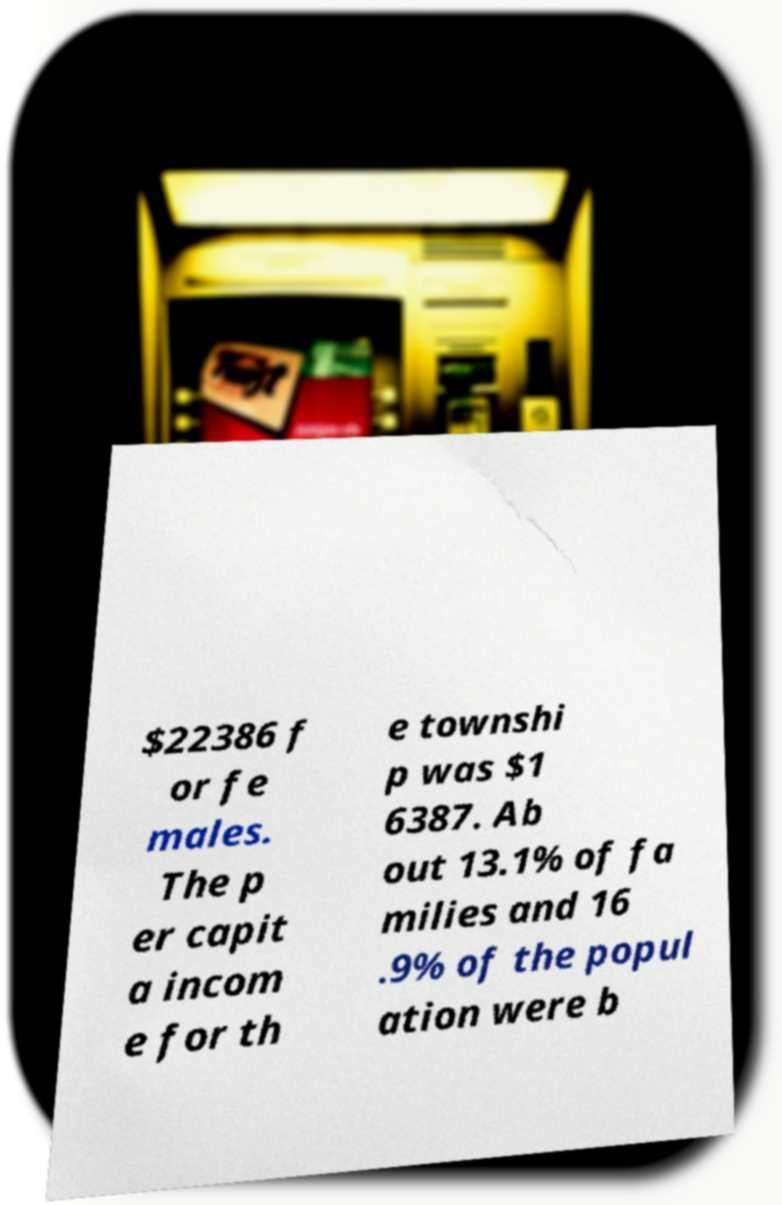Can you read and provide the text displayed in the image?This photo seems to have some interesting text. Can you extract and type it out for me? $22386 f or fe males. The p er capit a incom e for th e townshi p was $1 6387. Ab out 13.1% of fa milies and 16 .9% of the popul ation were b 